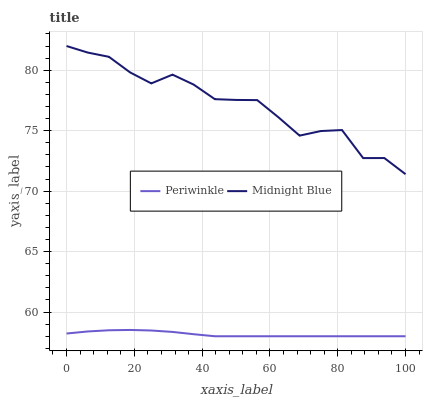Does Periwinkle have the minimum area under the curve?
Answer yes or no. Yes. Does Midnight Blue have the maximum area under the curve?
Answer yes or no. Yes. Does Midnight Blue have the minimum area under the curve?
Answer yes or no. No. Is Periwinkle the smoothest?
Answer yes or no. Yes. Is Midnight Blue the roughest?
Answer yes or no. Yes. Is Midnight Blue the smoothest?
Answer yes or no. No. Does Periwinkle have the lowest value?
Answer yes or no. Yes. Does Midnight Blue have the lowest value?
Answer yes or no. No. Does Midnight Blue have the highest value?
Answer yes or no. Yes. Is Periwinkle less than Midnight Blue?
Answer yes or no. Yes. Is Midnight Blue greater than Periwinkle?
Answer yes or no. Yes. Does Periwinkle intersect Midnight Blue?
Answer yes or no. No. 